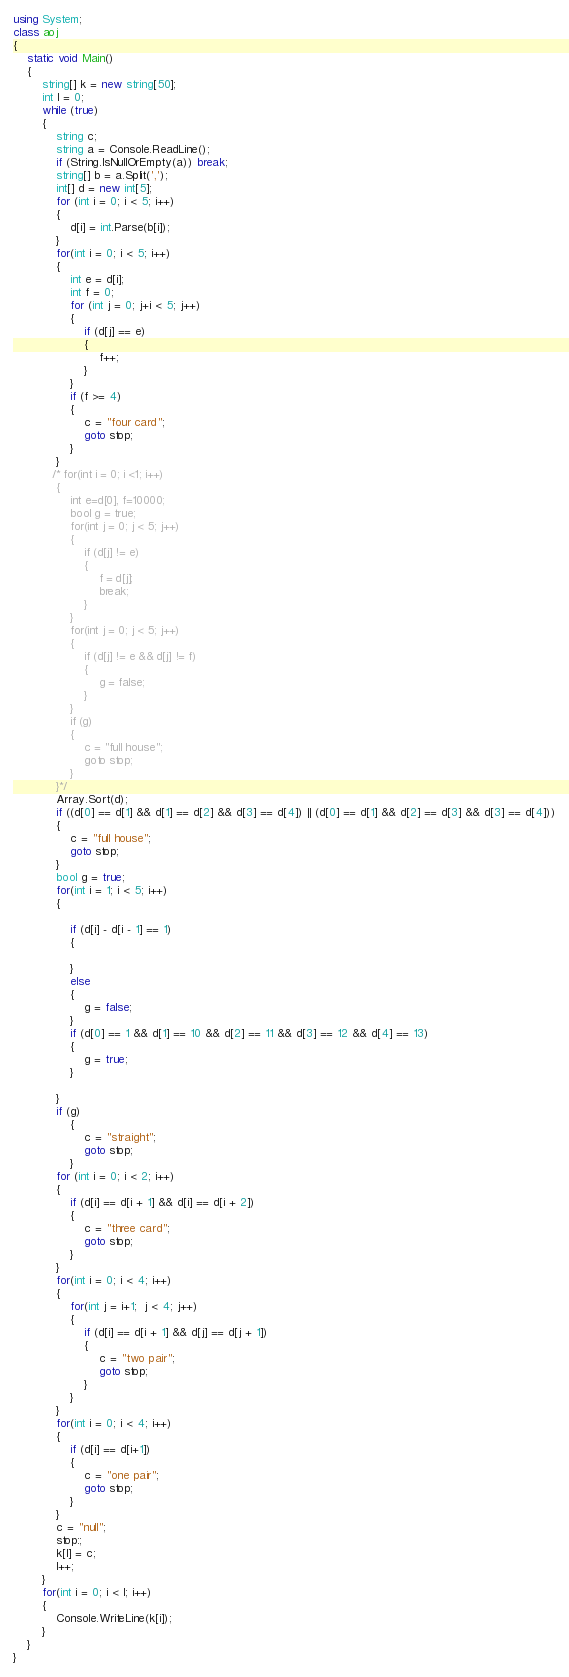Convert code to text. <code><loc_0><loc_0><loc_500><loc_500><_C#_>using System;
class aoj
{
    static void Main()
    {
        string[] k = new string[50];
        int l = 0;
        while (true)
        {
            string c;
            string a = Console.ReadLine();
            if (String.IsNullOrEmpty(a)) break;
            string[] b = a.Split(',');
            int[] d = new int[5];
            for (int i = 0; i < 5; i++)
            {
                d[i] = int.Parse(b[i]);
            }
            for(int i = 0; i < 5; i++)
            {
                int e = d[i];
                int f = 0;
                for (int j = 0; j+i < 5; j++)
                {
                    if (d[j] == e)
                    {
                        f++;
                    }
                }
                if (f >= 4)
                {
                    c = "four card";
                    goto stop;
                }
            }
           /* for(int i = 0; i <1; i++)
            {
                int e=d[0], f=10000;
                bool g = true;
                for(int j = 0; j < 5; j++)
                {
                    if (d[j] != e)
                    {
                        f = d[j];
                        break;
                    }
                }
                for(int j = 0; j < 5; j++)
                {
                    if (d[j] != e && d[j] != f)
                    {
                        g = false;
                    }
                }
                if (g)
                {
                    c = "full house";
                    goto stop;
                }
            }*/
            Array.Sort(d);
            if ((d[0] == d[1] && d[1] == d[2] && d[3] == d[4]) || (d[0] == d[1] && d[2] == d[3] && d[3] == d[4]))
            {
                c = "full house";
                goto stop;
            }
            bool g = true;
            for(int i = 1; i < 5; i++)
            {
                
                if (d[i] - d[i - 1] == 1)
                {

                }
                else
                {
                    g = false;
                }
                if (d[0] == 1 && d[1] == 10 && d[2] == 11 && d[3] == 12 && d[4] == 13)
                {
                    g = true;
                }
               
            }
            if (g)
                {
                    c = "straight";
                    goto stop;
                }
            for (int i = 0; i < 2; i++)
            {
                if (d[i] == d[i + 1] && d[i] == d[i + 2])
                {
                    c = "three card";
                    goto stop;
                }
            }
            for(int i = 0; i < 4; i++)
            {
                for(int j = i+1;  j < 4; j++)
                {
                    if (d[i] == d[i + 1] && d[j] == d[j + 1])
                    {
                        c = "two pair";
                        goto stop;
                    }
                }
            }
            for(int i = 0; i < 4; i++)
            {
                if (d[i] == d[i+1])
                {
                    c = "one pair";
                    goto stop;
                }
            }
            c = "null";
            stop:;
            k[l] = c;
            l++;
        }
        for(int i = 0; i < l; i++)
        {
            Console.WriteLine(k[i]);
        }
    }
}</code> 